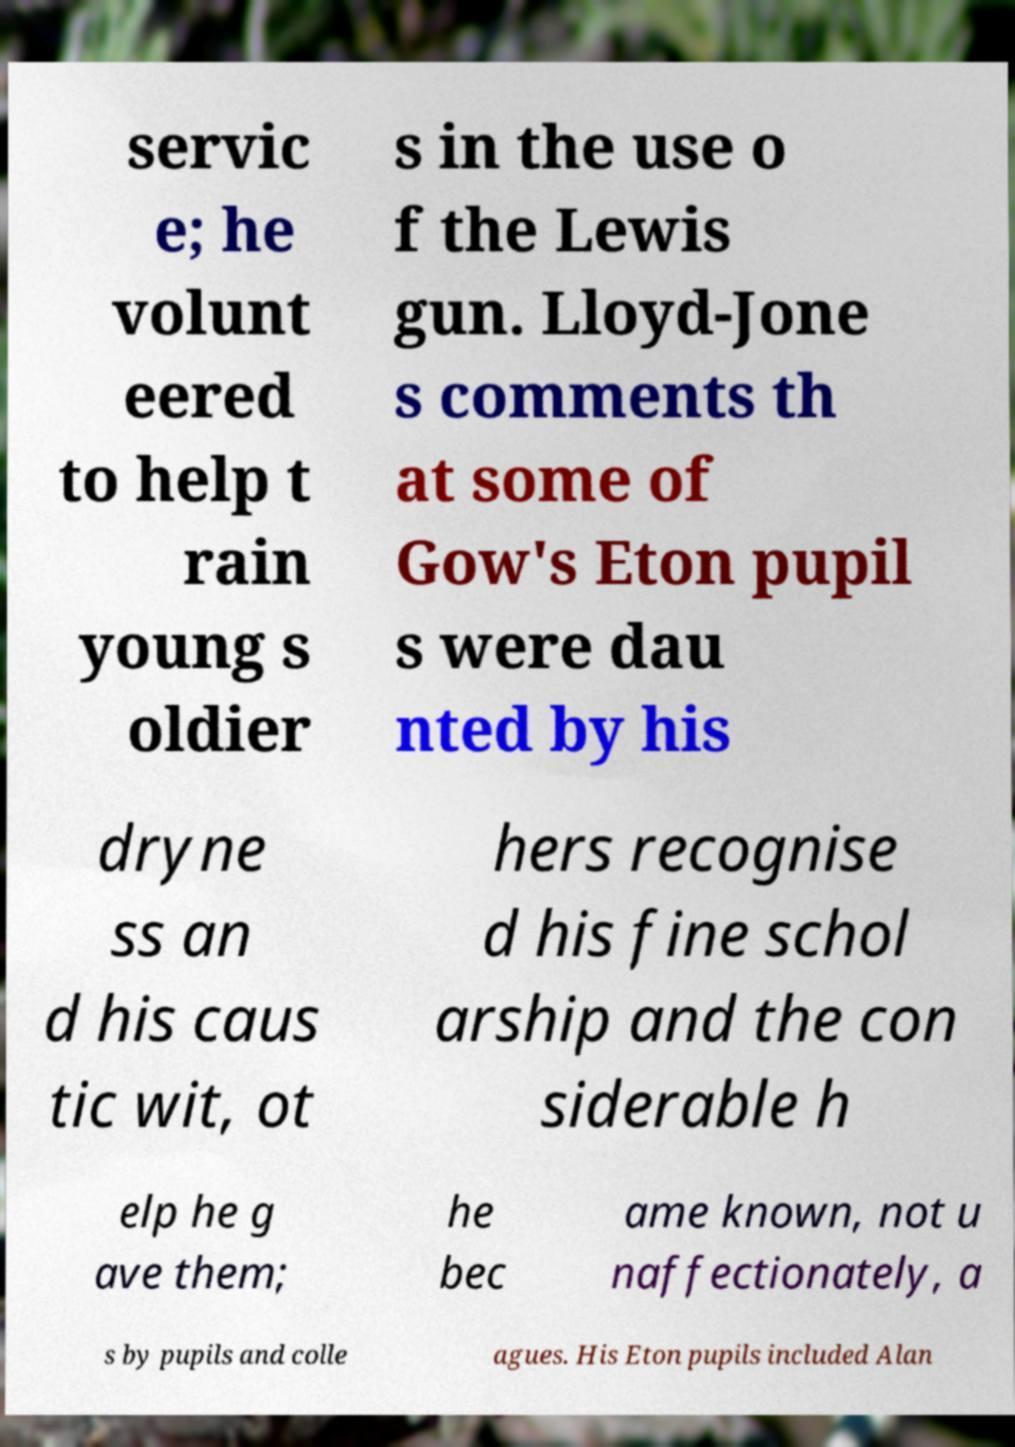Can you accurately transcribe the text from the provided image for me? servic e; he volunt eered to help t rain young s oldier s in the use o f the Lewis gun. Lloyd-Jone s comments th at some of Gow's Eton pupil s were dau nted by his dryne ss an d his caus tic wit, ot hers recognise d his fine schol arship and the con siderable h elp he g ave them; he bec ame known, not u naffectionately, a s by pupils and colle agues. His Eton pupils included Alan 